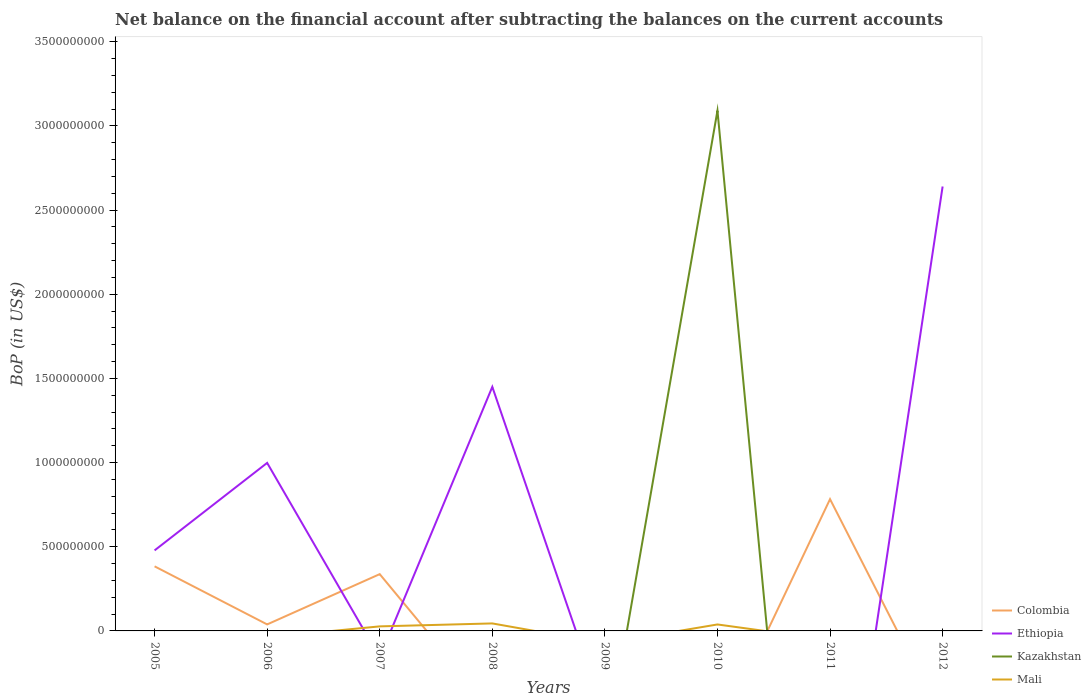How many different coloured lines are there?
Provide a short and direct response. 4. Does the line corresponding to Colombia intersect with the line corresponding to Kazakhstan?
Ensure brevity in your answer.  Yes. Across all years, what is the maximum Balance of Payments in Mali?
Make the answer very short. 0. What is the difference between the highest and the second highest Balance of Payments in Mali?
Give a very brief answer. 4.45e+07. What is the difference between the highest and the lowest Balance of Payments in Kazakhstan?
Provide a short and direct response. 1. Is the Balance of Payments in Mali strictly greater than the Balance of Payments in Ethiopia over the years?
Your answer should be very brief. No. How many years are there in the graph?
Offer a terse response. 8. How many legend labels are there?
Your answer should be compact. 4. What is the title of the graph?
Give a very brief answer. Net balance on the financial account after subtracting the balances on the current accounts. Does "Albania" appear as one of the legend labels in the graph?
Offer a very short reply. No. What is the label or title of the Y-axis?
Your answer should be very brief. BoP (in US$). What is the BoP (in US$) in Colombia in 2005?
Offer a very short reply. 3.84e+08. What is the BoP (in US$) of Ethiopia in 2005?
Ensure brevity in your answer.  4.78e+08. What is the BoP (in US$) in Kazakhstan in 2005?
Your answer should be compact. 0. What is the BoP (in US$) in Mali in 2005?
Give a very brief answer. 0. What is the BoP (in US$) of Colombia in 2006?
Offer a terse response. 3.87e+07. What is the BoP (in US$) in Ethiopia in 2006?
Offer a terse response. 9.98e+08. What is the BoP (in US$) in Mali in 2006?
Offer a terse response. 0. What is the BoP (in US$) of Colombia in 2007?
Provide a short and direct response. 3.37e+08. What is the BoP (in US$) of Ethiopia in 2007?
Offer a terse response. 0. What is the BoP (in US$) in Mali in 2007?
Provide a succinct answer. 2.70e+07. What is the BoP (in US$) in Colombia in 2008?
Your response must be concise. 0. What is the BoP (in US$) in Ethiopia in 2008?
Your answer should be compact. 1.45e+09. What is the BoP (in US$) in Kazakhstan in 2008?
Keep it short and to the point. 0. What is the BoP (in US$) of Mali in 2008?
Your answer should be compact. 4.45e+07. What is the BoP (in US$) of Ethiopia in 2009?
Your answer should be compact. 0. What is the BoP (in US$) in Mali in 2009?
Offer a very short reply. 0. What is the BoP (in US$) of Kazakhstan in 2010?
Offer a very short reply. 3.09e+09. What is the BoP (in US$) of Mali in 2010?
Your answer should be compact. 3.84e+07. What is the BoP (in US$) of Colombia in 2011?
Offer a very short reply. 7.83e+08. What is the BoP (in US$) in Ethiopia in 2011?
Offer a very short reply. 0. What is the BoP (in US$) in Kazakhstan in 2011?
Make the answer very short. 0. What is the BoP (in US$) of Mali in 2011?
Your response must be concise. 0. What is the BoP (in US$) of Colombia in 2012?
Offer a very short reply. 0. What is the BoP (in US$) of Ethiopia in 2012?
Your response must be concise. 2.64e+09. What is the BoP (in US$) in Mali in 2012?
Your answer should be compact. 0. Across all years, what is the maximum BoP (in US$) in Colombia?
Your answer should be compact. 7.83e+08. Across all years, what is the maximum BoP (in US$) in Ethiopia?
Offer a very short reply. 2.64e+09. Across all years, what is the maximum BoP (in US$) of Kazakhstan?
Offer a very short reply. 3.09e+09. Across all years, what is the maximum BoP (in US$) of Mali?
Make the answer very short. 4.45e+07. Across all years, what is the minimum BoP (in US$) in Colombia?
Provide a succinct answer. 0. Across all years, what is the minimum BoP (in US$) in Mali?
Give a very brief answer. 0. What is the total BoP (in US$) in Colombia in the graph?
Your response must be concise. 1.54e+09. What is the total BoP (in US$) in Ethiopia in the graph?
Keep it short and to the point. 5.57e+09. What is the total BoP (in US$) in Kazakhstan in the graph?
Provide a succinct answer. 3.09e+09. What is the total BoP (in US$) in Mali in the graph?
Offer a terse response. 1.10e+08. What is the difference between the BoP (in US$) in Colombia in 2005 and that in 2006?
Give a very brief answer. 3.45e+08. What is the difference between the BoP (in US$) in Ethiopia in 2005 and that in 2006?
Keep it short and to the point. -5.20e+08. What is the difference between the BoP (in US$) in Colombia in 2005 and that in 2007?
Give a very brief answer. 4.63e+07. What is the difference between the BoP (in US$) in Ethiopia in 2005 and that in 2008?
Give a very brief answer. -9.72e+08. What is the difference between the BoP (in US$) in Colombia in 2005 and that in 2011?
Your response must be concise. -3.99e+08. What is the difference between the BoP (in US$) of Ethiopia in 2005 and that in 2012?
Offer a terse response. -2.16e+09. What is the difference between the BoP (in US$) in Colombia in 2006 and that in 2007?
Ensure brevity in your answer.  -2.99e+08. What is the difference between the BoP (in US$) in Ethiopia in 2006 and that in 2008?
Provide a succinct answer. -4.52e+08. What is the difference between the BoP (in US$) in Colombia in 2006 and that in 2011?
Offer a very short reply. -7.44e+08. What is the difference between the BoP (in US$) of Ethiopia in 2006 and that in 2012?
Offer a terse response. -1.64e+09. What is the difference between the BoP (in US$) in Mali in 2007 and that in 2008?
Your answer should be compact. -1.75e+07. What is the difference between the BoP (in US$) in Mali in 2007 and that in 2010?
Keep it short and to the point. -1.14e+07. What is the difference between the BoP (in US$) in Colombia in 2007 and that in 2011?
Make the answer very short. -4.46e+08. What is the difference between the BoP (in US$) of Mali in 2008 and that in 2010?
Offer a terse response. 6.10e+06. What is the difference between the BoP (in US$) in Ethiopia in 2008 and that in 2012?
Provide a succinct answer. -1.19e+09. What is the difference between the BoP (in US$) of Colombia in 2005 and the BoP (in US$) of Ethiopia in 2006?
Your answer should be very brief. -6.15e+08. What is the difference between the BoP (in US$) of Colombia in 2005 and the BoP (in US$) of Mali in 2007?
Offer a very short reply. 3.57e+08. What is the difference between the BoP (in US$) in Ethiopia in 2005 and the BoP (in US$) in Mali in 2007?
Offer a terse response. 4.51e+08. What is the difference between the BoP (in US$) in Colombia in 2005 and the BoP (in US$) in Ethiopia in 2008?
Offer a terse response. -1.07e+09. What is the difference between the BoP (in US$) of Colombia in 2005 and the BoP (in US$) of Mali in 2008?
Make the answer very short. 3.39e+08. What is the difference between the BoP (in US$) of Ethiopia in 2005 and the BoP (in US$) of Mali in 2008?
Offer a terse response. 4.34e+08. What is the difference between the BoP (in US$) of Colombia in 2005 and the BoP (in US$) of Kazakhstan in 2010?
Make the answer very short. -2.71e+09. What is the difference between the BoP (in US$) in Colombia in 2005 and the BoP (in US$) in Mali in 2010?
Make the answer very short. 3.45e+08. What is the difference between the BoP (in US$) in Ethiopia in 2005 and the BoP (in US$) in Kazakhstan in 2010?
Your answer should be very brief. -2.61e+09. What is the difference between the BoP (in US$) in Ethiopia in 2005 and the BoP (in US$) in Mali in 2010?
Your answer should be compact. 4.40e+08. What is the difference between the BoP (in US$) in Colombia in 2005 and the BoP (in US$) in Ethiopia in 2012?
Offer a very short reply. -2.26e+09. What is the difference between the BoP (in US$) of Colombia in 2006 and the BoP (in US$) of Mali in 2007?
Provide a short and direct response. 1.17e+07. What is the difference between the BoP (in US$) in Ethiopia in 2006 and the BoP (in US$) in Mali in 2007?
Give a very brief answer. 9.71e+08. What is the difference between the BoP (in US$) in Colombia in 2006 and the BoP (in US$) in Ethiopia in 2008?
Ensure brevity in your answer.  -1.41e+09. What is the difference between the BoP (in US$) of Colombia in 2006 and the BoP (in US$) of Mali in 2008?
Provide a short and direct response. -5.85e+06. What is the difference between the BoP (in US$) in Ethiopia in 2006 and the BoP (in US$) in Mali in 2008?
Keep it short and to the point. 9.54e+08. What is the difference between the BoP (in US$) of Colombia in 2006 and the BoP (in US$) of Kazakhstan in 2010?
Offer a terse response. -3.05e+09. What is the difference between the BoP (in US$) in Colombia in 2006 and the BoP (in US$) in Mali in 2010?
Provide a succinct answer. 2.50e+05. What is the difference between the BoP (in US$) in Ethiopia in 2006 and the BoP (in US$) in Kazakhstan in 2010?
Your answer should be very brief. -2.09e+09. What is the difference between the BoP (in US$) in Ethiopia in 2006 and the BoP (in US$) in Mali in 2010?
Ensure brevity in your answer.  9.60e+08. What is the difference between the BoP (in US$) of Colombia in 2006 and the BoP (in US$) of Ethiopia in 2012?
Offer a very short reply. -2.60e+09. What is the difference between the BoP (in US$) in Colombia in 2007 and the BoP (in US$) in Ethiopia in 2008?
Offer a terse response. -1.11e+09. What is the difference between the BoP (in US$) in Colombia in 2007 and the BoP (in US$) in Mali in 2008?
Your answer should be very brief. 2.93e+08. What is the difference between the BoP (in US$) in Colombia in 2007 and the BoP (in US$) in Kazakhstan in 2010?
Provide a succinct answer. -2.75e+09. What is the difference between the BoP (in US$) in Colombia in 2007 and the BoP (in US$) in Mali in 2010?
Ensure brevity in your answer.  2.99e+08. What is the difference between the BoP (in US$) in Colombia in 2007 and the BoP (in US$) in Ethiopia in 2012?
Make the answer very short. -2.30e+09. What is the difference between the BoP (in US$) of Ethiopia in 2008 and the BoP (in US$) of Kazakhstan in 2010?
Give a very brief answer. -1.64e+09. What is the difference between the BoP (in US$) in Ethiopia in 2008 and the BoP (in US$) in Mali in 2010?
Offer a very short reply. 1.41e+09. What is the difference between the BoP (in US$) of Colombia in 2011 and the BoP (in US$) of Ethiopia in 2012?
Your answer should be very brief. -1.86e+09. What is the average BoP (in US$) of Colombia per year?
Your answer should be very brief. 1.93e+08. What is the average BoP (in US$) of Ethiopia per year?
Offer a terse response. 6.96e+08. What is the average BoP (in US$) of Kazakhstan per year?
Make the answer very short. 3.86e+08. What is the average BoP (in US$) of Mali per year?
Your answer should be compact. 1.37e+07. In the year 2005, what is the difference between the BoP (in US$) of Colombia and BoP (in US$) of Ethiopia?
Give a very brief answer. -9.47e+07. In the year 2006, what is the difference between the BoP (in US$) of Colombia and BoP (in US$) of Ethiopia?
Offer a terse response. -9.60e+08. In the year 2007, what is the difference between the BoP (in US$) in Colombia and BoP (in US$) in Mali?
Provide a short and direct response. 3.10e+08. In the year 2008, what is the difference between the BoP (in US$) in Ethiopia and BoP (in US$) in Mali?
Ensure brevity in your answer.  1.41e+09. In the year 2010, what is the difference between the BoP (in US$) in Kazakhstan and BoP (in US$) in Mali?
Keep it short and to the point. 3.05e+09. What is the ratio of the BoP (in US$) in Colombia in 2005 to that in 2006?
Offer a terse response. 9.93. What is the ratio of the BoP (in US$) of Ethiopia in 2005 to that in 2006?
Provide a short and direct response. 0.48. What is the ratio of the BoP (in US$) in Colombia in 2005 to that in 2007?
Offer a very short reply. 1.14. What is the ratio of the BoP (in US$) in Ethiopia in 2005 to that in 2008?
Make the answer very short. 0.33. What is the ratio of the BoP (in US$) in Colombia in 2005 to that in 2011?
Your response must be concise. 0.49. What is the ratio of the BoP (in US$) of Ethiopia in 2005 to that in 2012?
Provide a short and direct response. 0.18. What is the ratio of the BoP (in US$) of Colombia in 2006 to that in 2007?
Your answer should be very brief. 0.11. What is the ratio of the BoP (in US$) in Ethiopia in 2006 to that in 2008?
Give a very brief answer. 0.69. What is the ratio of the BoP (in US$) of Colombia in 2006 to that in 2011?
Provide a short and direct response. 0.05. What is the ratio of the BoP (in US$) of Ethiopia in 2006 to that in 2012?
Give a very brief answer. 0.38. What is the ratio of the BoP (in US$) in Mali in 2007 to that in 2008?
Make the answer very short. 0.61. What is the ratio of the BoP (in US$) in Mali in 2007 to that in 2010?
Your response must be concise. 0.7. What is the ratio of the BoP (in US$) in Colombia in 2007 to that in 2011?
Give a very brief answer. 0.43. What is the ratio of the BoP (in US$) in Mali in 2008 to that in 2010?
Keep it short and to the point. 1.16. What is the ratio of the BoP (in US$) of Ethiopia in 2008 to that in 2012?
Provide a succinct answer. 0.55. What is the difference between the highest and the second highest BoP (in US$) in Colombia?
Keep it short and to the point. 3.99e+08. What is the difference between the highest and the second highest BoP (in US$) in Ethiopia?
Provide a succinct answer. 1.19e+09. What is the difference between the highest and the second highest BoP (in US$) in Mali?
Make the answer very short. 6.10e+06. What is the difference between the highest and the lowest BoP (in US$) of Colombia?
Give a very brief answer. 7.83e+08. What is the difference between the highest and the lowest BoP (in US$) of Ethiopia?
Make the answer very short. 2.64e+09. What is the difference between the highest and the lowest BoP (in US$) of Kazakhstan?
Provide a short and direct response. 3.09e+09. What is the difference between the highest and the lowest BoP (in US$) of Mali?
Offer a terse response. 4.45e+07. 